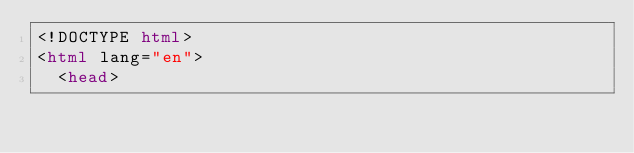Convert code to text. <code><loc_0><loc_0><loc_500><loc_500><_HTML_><!DOCTYPE html>
<html lang="en">
  <head></code> 